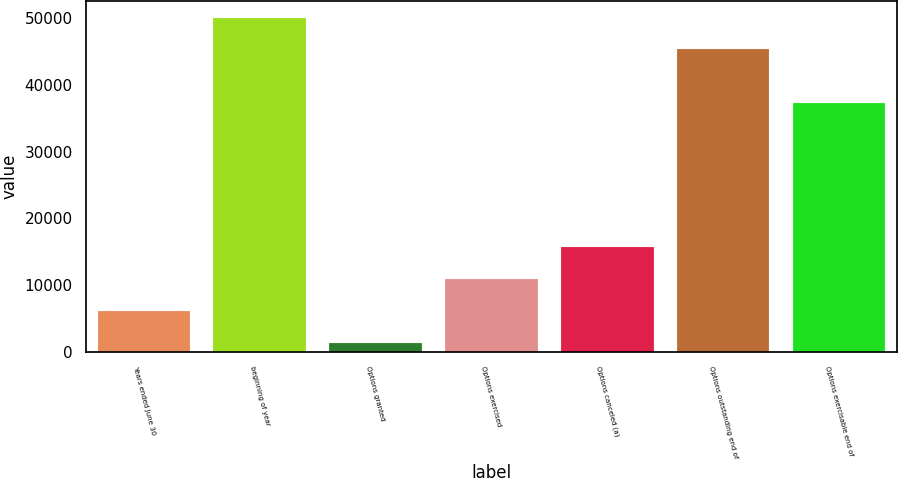Convert chart. <chart><loc_0><loc_0><loc_500><loc_500><bar_chart><fcel>Years ended June 30<fcel>beginning of year<fcel>Options granted<fcel>Options exercised<fcel>Options canceled (a)<fcel>Options outstanding end of<fcel>Options exercisable end of<nl><fcel>6163.7<fcel>50093.7<fcel>1390<fcel>10937.4<fcel>15711.1<fcel>45320<fcel>37318<nl></chart> 